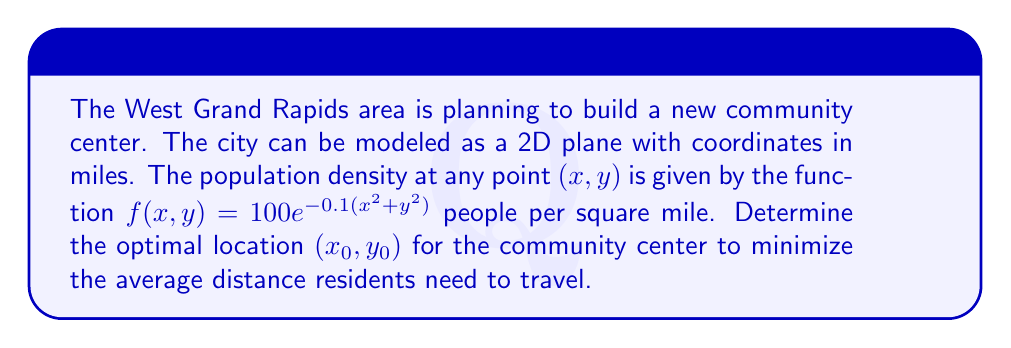Provide a solution to this math problem. To solve this inverse problem, we'll follow these steps:

1) The objective function to minimize is the average distance from residents to the community center. This can be expressed as:

   $$J(x_0,y_0) = \frac{\int\int_R \sqrt{(x-x_0)^2 + (y-y_0)^2} f(x,y) \, dx \, dy}{\int\int_R f(x,y) \, dx \, dy}$$

   where $R$ is the entire plane.

2) Due to the symmetry of the population density function, we can deduce that the optimal location will be at the origin $(0,0)$. Let's prove this.

3) If we shift the coordinate system by $(x_0,y_0)$, the new density function becomes:

   $$f'(x,y) = 100e^{-0.1((x+x_0)^2+(y+y_0)^2)}$$

4) The numerator of $J(x_0,y_0)$ can be written as:

   $$\int\int_R \sqrt{x^2 + y^2} \cdot 100e^{-0.1((x+x_0)^2+(y+y_0)^2)} \, dx \, dy$$

5) This integral is minimized when $x_0 = y_0 = 0$, because any non-zero $(x_0,y_0)$ would shift the exponential term, increasing the average distance.

6) Therefore, the optimal location for the community center is at the origin $(0,0)$, which represents the center of the West Grand Rapids area in our model.

7) This solution aligns with the intuition that placing the center where the population density is highest (at the origin in this model) will minimize average travel distance for residents.
Answer: $(0,0)$ 